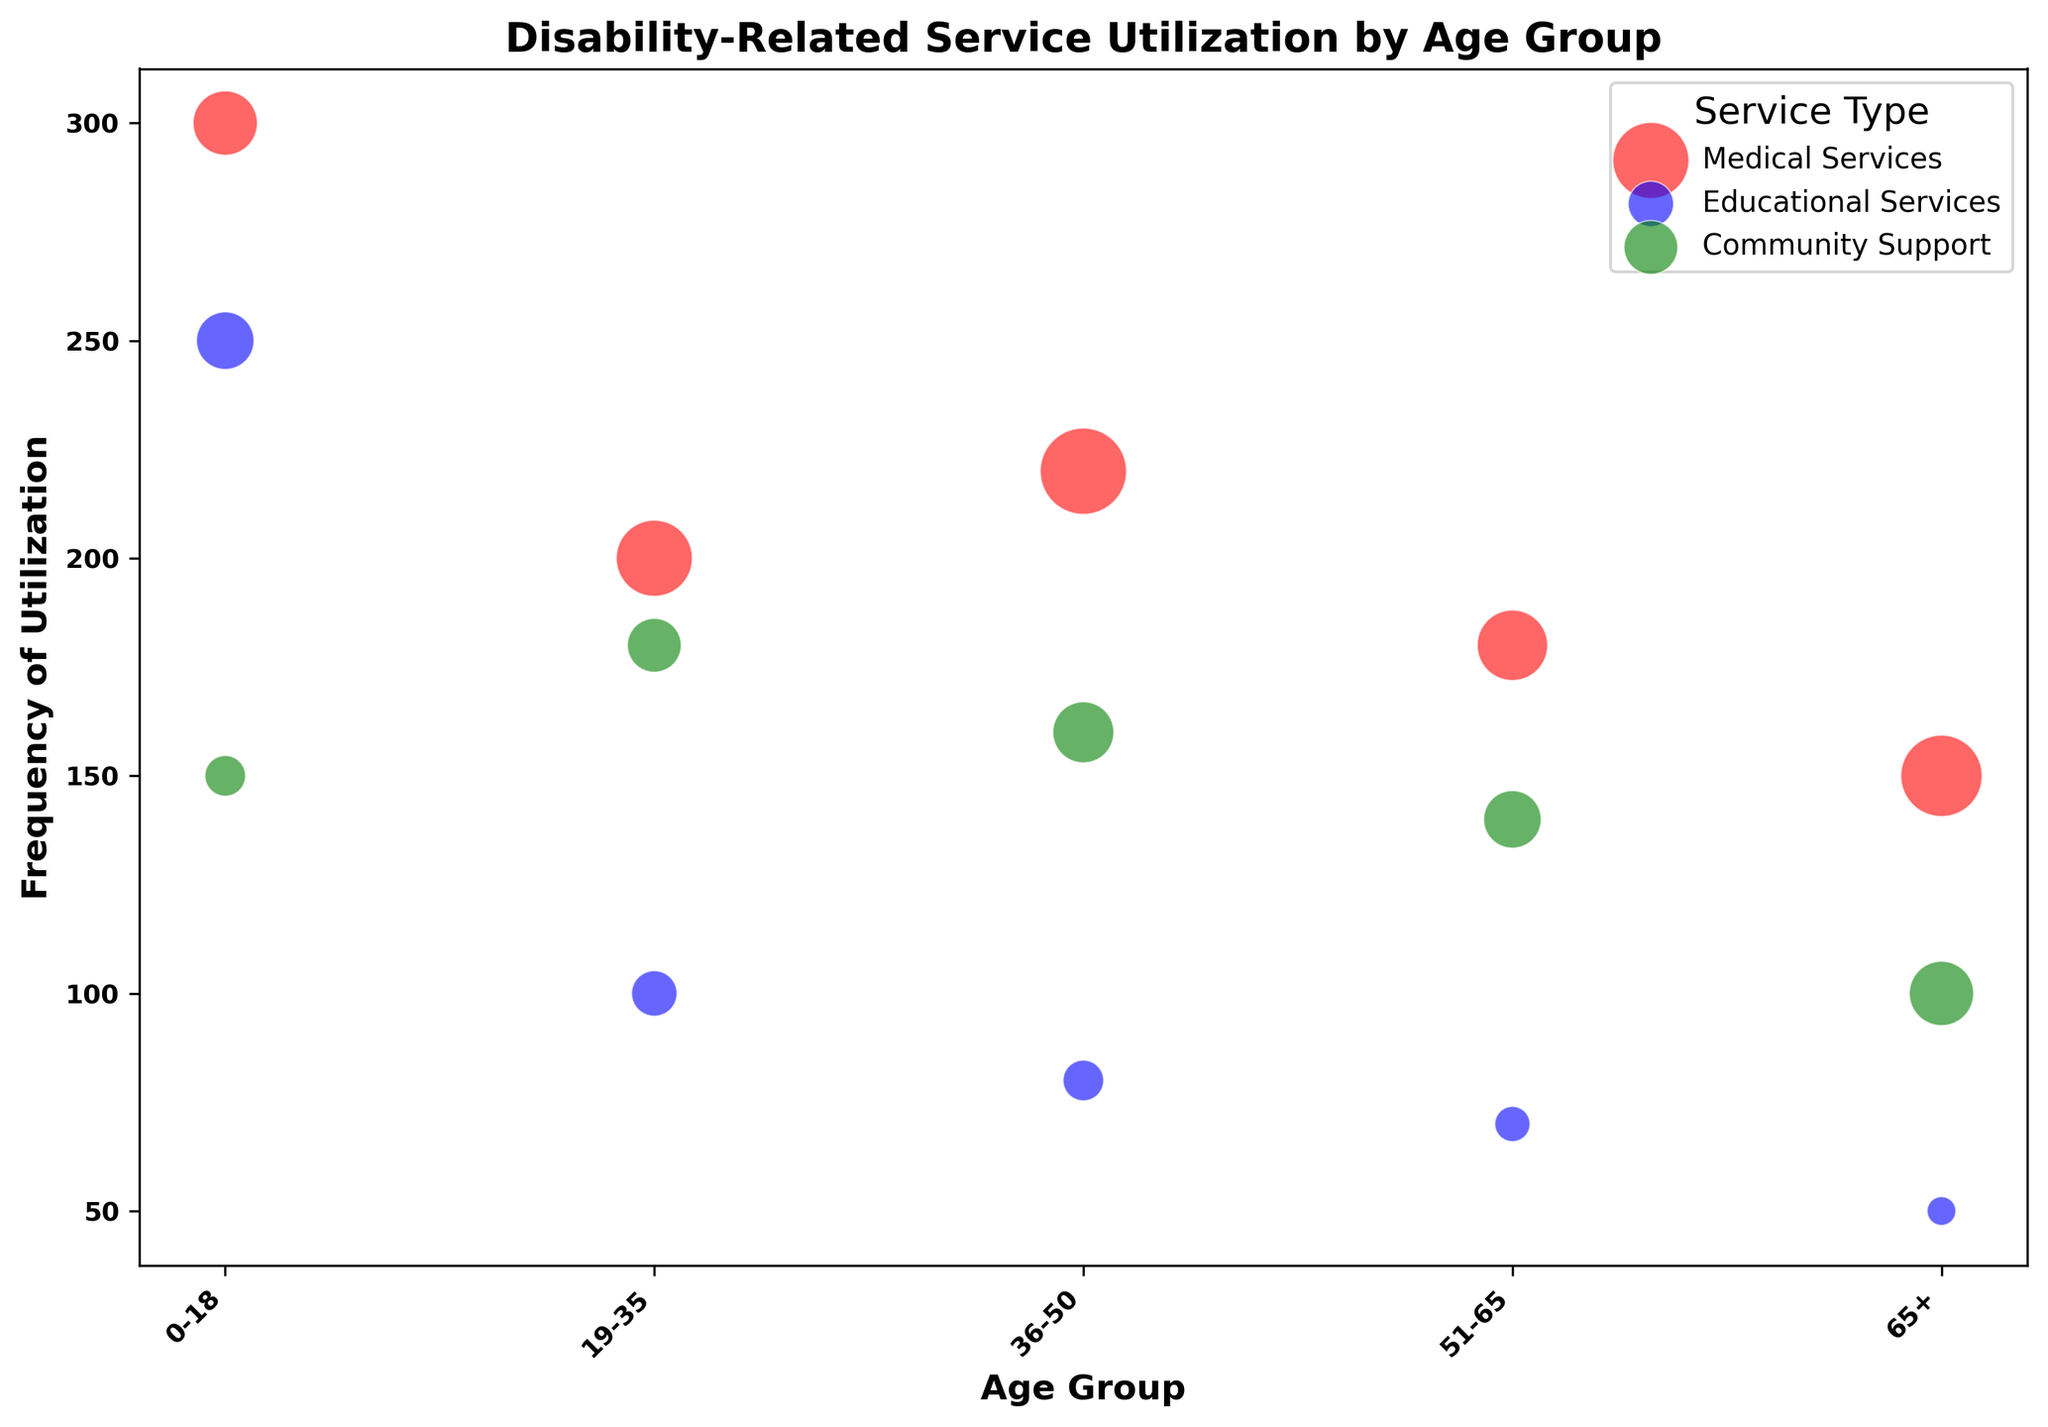Which age group has the highest frequency of Educational Services utilization? The frequency of Educational Services utilization is highest among the 0-18 age group, indicated by the blue bubble at the highest point on the frequency axis for this service.
Answer: 0-18 What is the total frequency of Medical Services utilization across all age groups? Adding the frequency values for Medical Services across all age groups: 300 (0-18) + 200 (19-35) + 220 (36-50) + 180 (51-65) + 150 (65+) results in a total of 1050.
Answer: 1050 How does the frequency of Community Support differ between the 19-35 and 65+ age groups? The frequency of Community Support for the 19-35 age group is 180 and for the 65+ age group is 100. The difference is 180 - 100 = 80.
Answer: 80 Which service has the largest bubble in the 36-50 age group? The bubble size corresponds to the service size. For the 36-50 age group, the largest bubble represents Medical Services.
Answer: Medical Services Is there any age group where the frequency for Medical Services is not the highest among the services? Checking each age group, Medical Services always has the highest frequency compared to Educational Services and Community Support.
Answer: No Which color is associated with Community Support in the plot? The bubbles representing Community Support are colored green.
Answer: Green In the 51-65 age group, which service has the smallest bubble? In the 51-65 age group, Educational Services has the smallest bubble.
Answer: Educational Services What's the average size of bubbles for Community Support across all age groups? The sizes for Community Support are 20 (0-18), 35 (19-35), 45 (36-50), 40 (51-65), and 50 (65+). The average is (20 + 35 + 45 + 40 + 50) / 5 = 38.
Answer: 38 